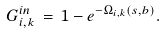Convert formula to latex. <formula><loc_0><loc_0><loc_500><loc_500>G _ { i , k } ^ { i n } \, = \, 1 - e ^ { - \Omega _ { i , k } ( s , b ) } .</formula> 